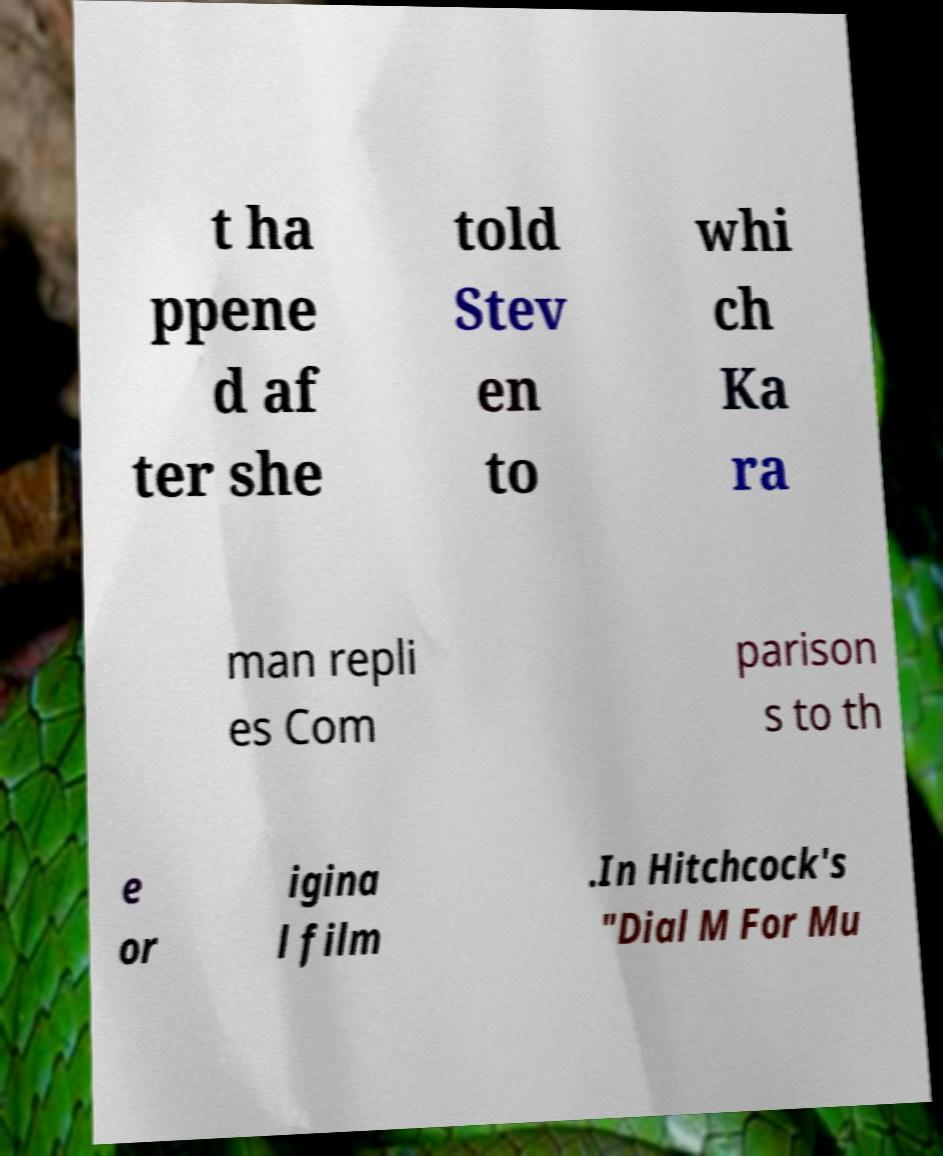I need the written content from this picture converted into text. Can you do that? t ha ppene d af ter she told Stev en to whi ch Ka ra man repli es Com parison s to th e or igina l film .In Hitchcock's "Dial M For Mu 